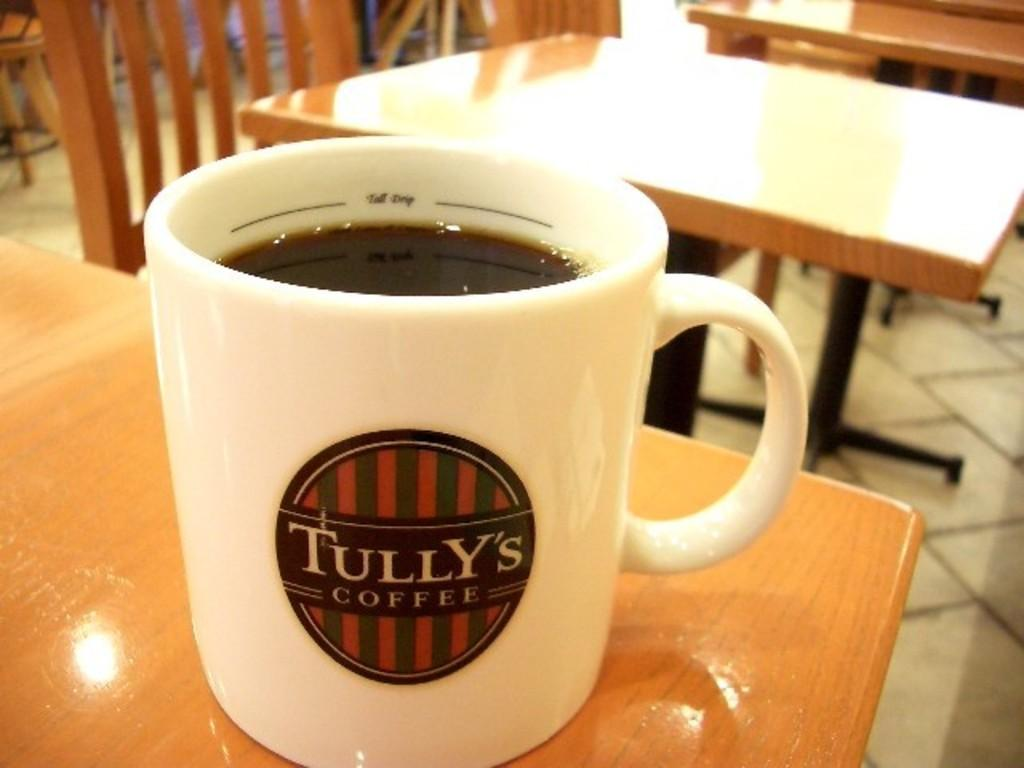What is in the cup that is visible in the image? The cup contains a drink. Where is the cup located in the image? The cup is on a table. What else can be seen in the background of the image? There are chairs and tables in the background of the image. How does the dirt affect the example of digestion in the image? There is no dirt or example of digestion present in the image. 